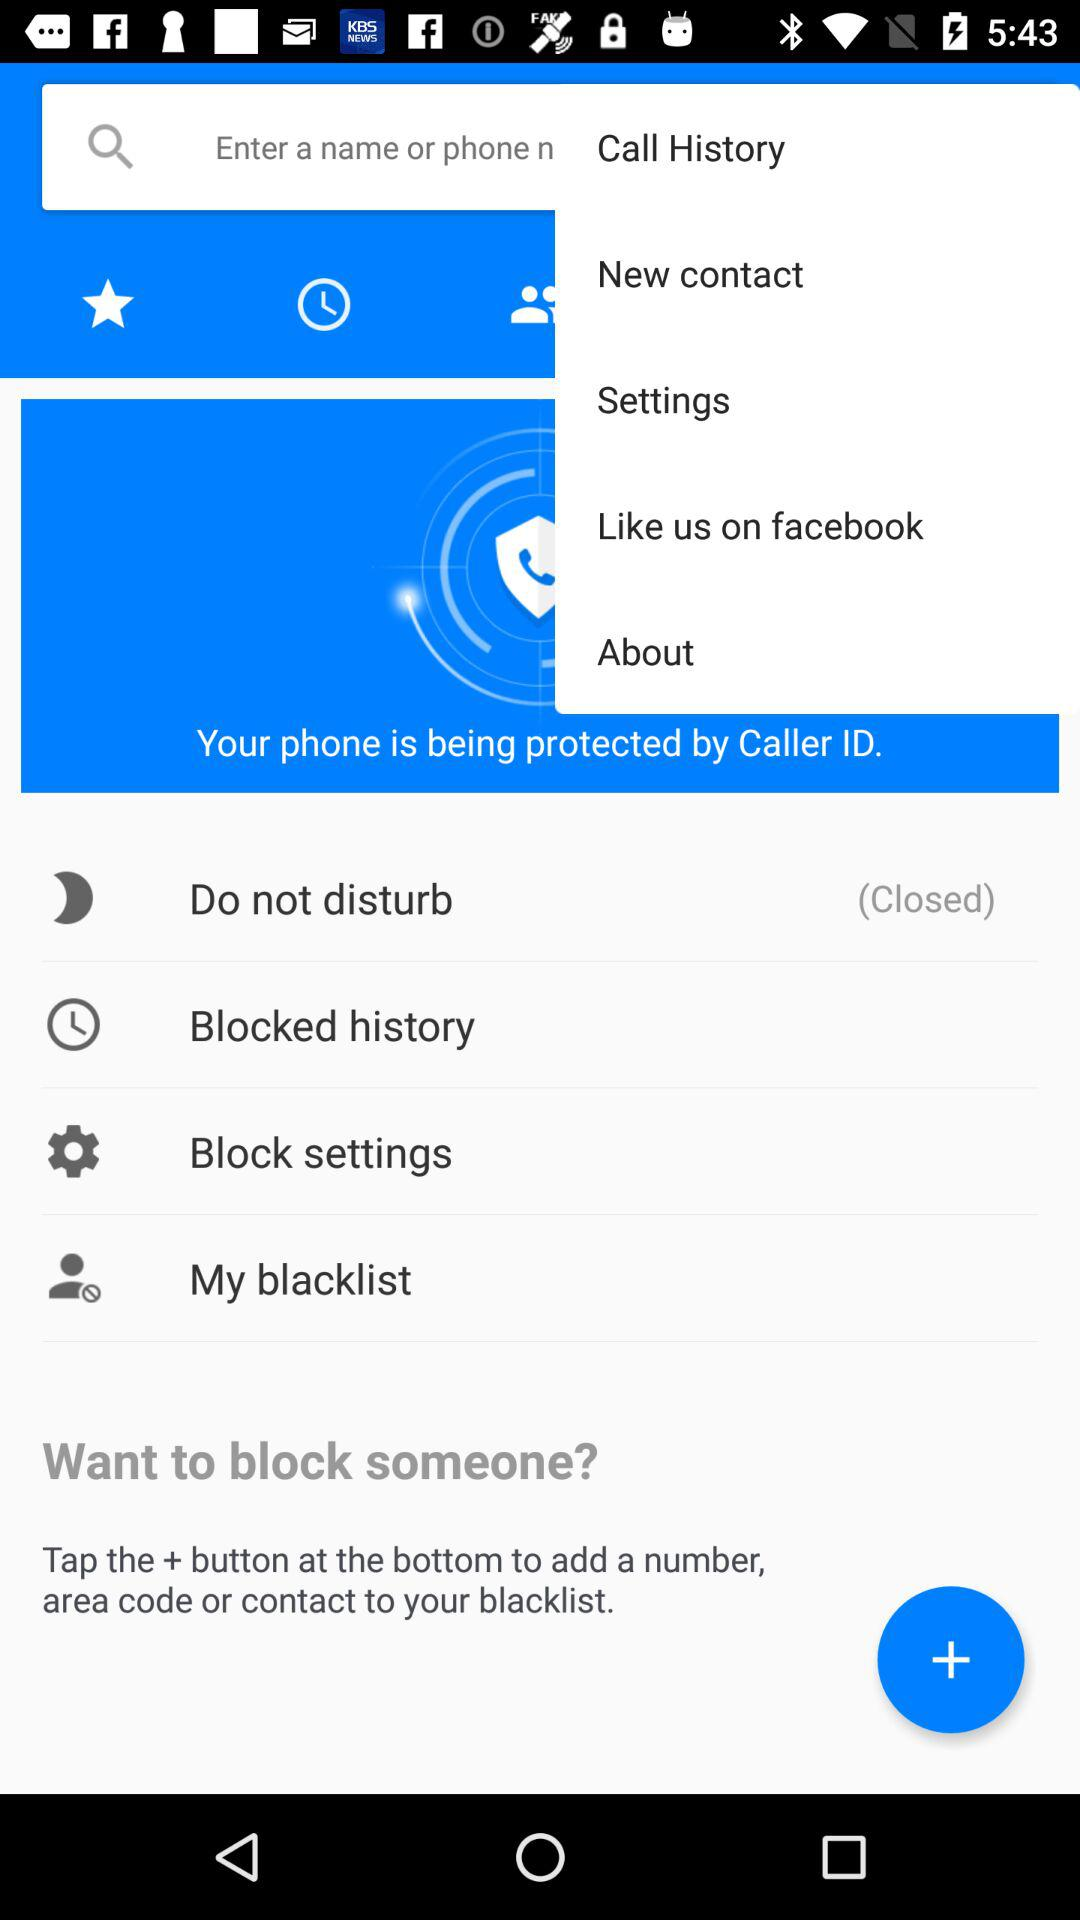What is the status of "Do not disturb"? The status is "Closed". 